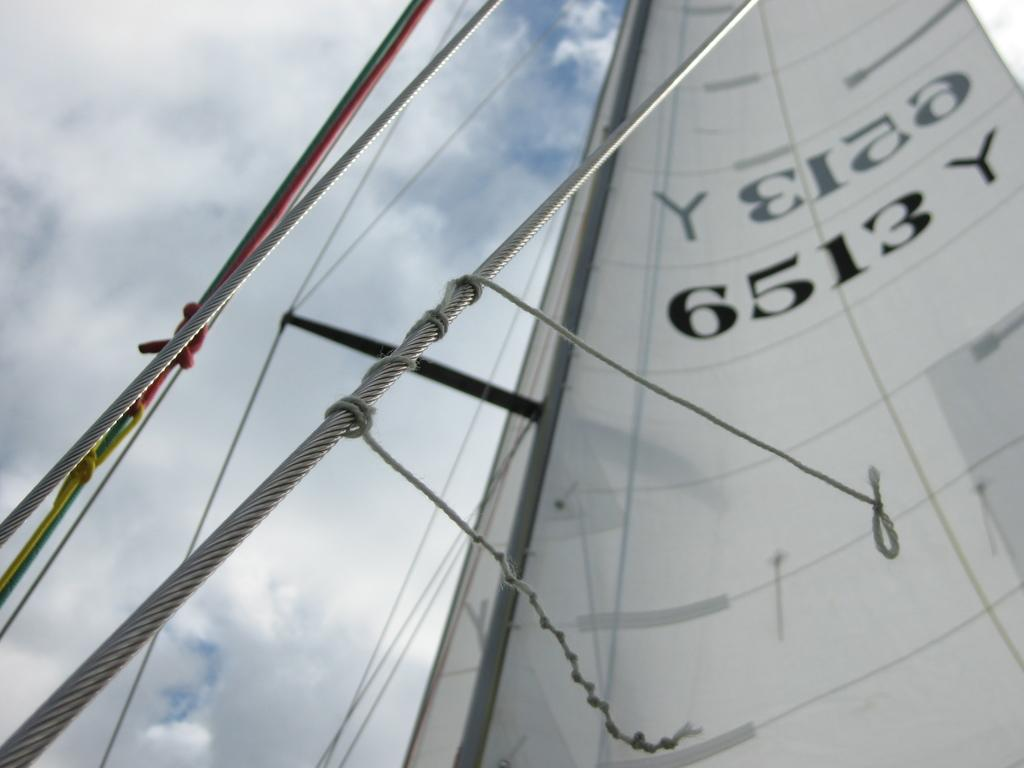What is the main subject in the center of the image? There is a boat in the center of the image. What can be seen in the background of the image? There is sky visible in the background of the image, and there are clouds present as well. What value does the mom place on the chess game in the image? There is no mom or chess game present in the image, so it is not possible to determine the value placed on a chess game by a mom. 